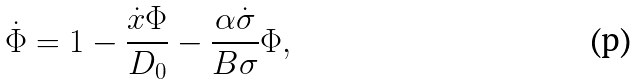<formula> <loc_0><loc_0><loc_500><loc_500>\dot { \Phi } = 1 - \frac { \dot { x } \Phi } { D _ { 0 } } - \frac { \alpha \dot { \sigma } } { B \sigma } \Phi ,</formula> 